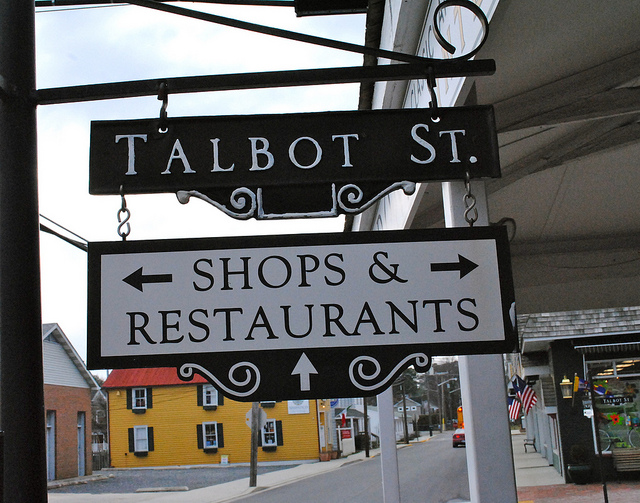What kind of atmosphere does the street show in the image suggest? The street has a quaint, small-town charm with its clear signage and clean sidewalks. The visibility of the American flag hints at a sense of community pride. The combination of commercial and residential buildings suggests a welcoming neighborhood for visitors and locals alike. 